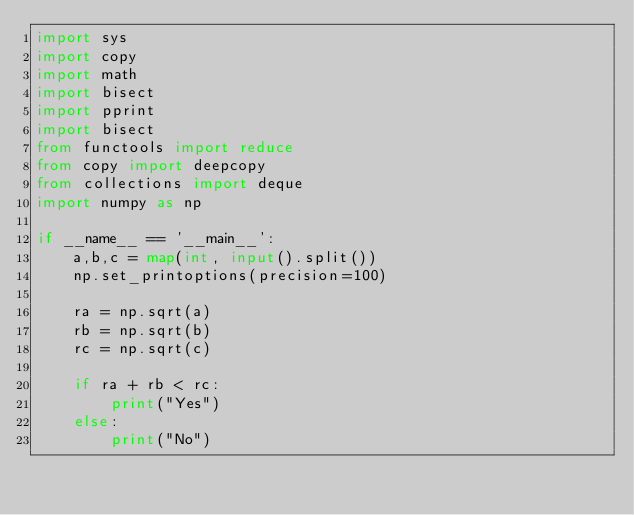Convert code to text. <code><loc_0><loc_0><loc_500><loc_500><_Python_>import sys
import copy
import math
import bisect
import pprint
import bisect
from functools import reduce
from copy import deepcopy
from collections import deque
import numpy as np

if __name__ == '__main__':
    a,b,c = map(int, input().split())
    np.set_printoptions(precision=100)

    ra = np.sqrt(a)
    rb = np.sqrt(b)
    rc = np.sqrt(c)
    
    if ra + rb < rc:
        print("Yes")
    else:
        print("No")</code> 